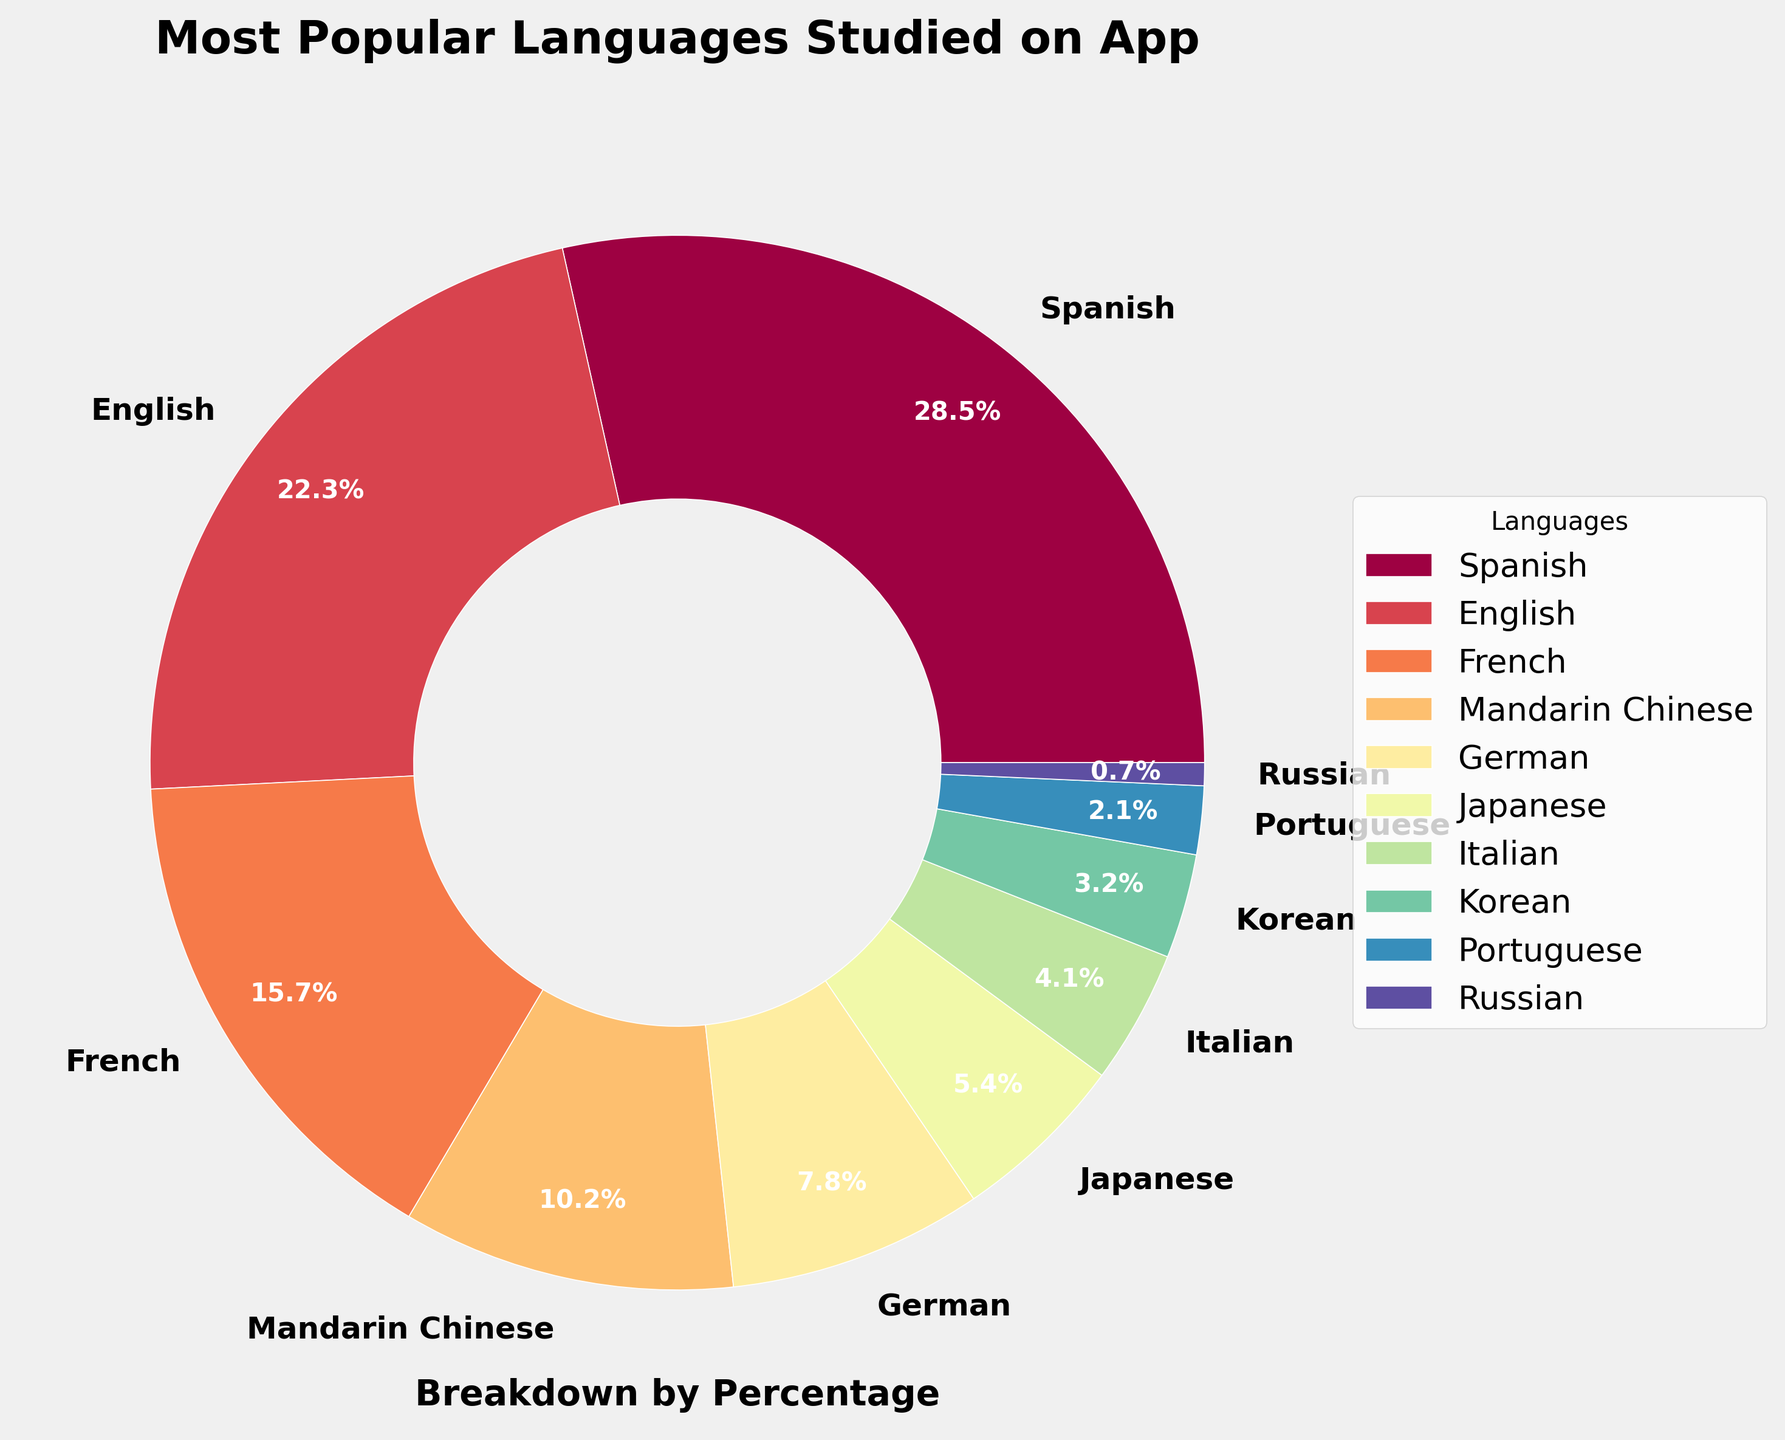What's the most popular language studied on the app? The pie chart shows the distribution of language popularity on the app. The Spanish section is the largest, making it the most popular language.
Answer: Spanish Which language has the smallest percentage of learners? By examining the pie chart, the smallest segment represents the language with the lowest percentage. In this case, it's Russian with 0.7%.
Answer: Russian How much higher is the percentage of learners studying Spanish compared to Mandarin Chinese? Spanish has 28.5% of learners, and Mandarin Chinese has 10.2%. Subtracting the two percentages: 28.5% - 10.2% = 18.3%.
Answer: 18.3% What is the combined percentage of learners studying Japanese and Korean? Japanese has 5.4%, and Korean has 3.2%. Adding these percentages together: 5.4% + 3.2% = 8.6%.
Answer: 8.6% Does French have a higher or lower percentage of learners than German? The pie chart shows that French has 15.7% and German has 7.8%. Since 15.7% is greater than 7.8%, French has a higher percentage.
Answer: Higher What is the percentage difference between English and French learners? English has 22.3%, and French has 15.7%. Subtracting the two percentages: 22.3% - 15.7% = 6.6%.
Answer: 6.6% Which segment in the pie chart is light blue, and what percentage does it represent? The light blue segment represents Mandarin Chinese, which has a 10.2% share.
Answer: Mandarin Chinese, 10.2% How many languages have more than 10% of learners? By examining the pie chart, Spanish, English, and French each have more than 10%. There are 3 languages in total.
Answer: 3 What is the combined percentage of learners studying the least popular three languages? The least popular three languages are Russian (0.7%), Portuguese (2.1%), and Korean (3.2%). Adding these percentages together: 0.7% + 2.1% + 3.2% = 6%.
Answer: 6% Among Spanish, French, and Italian, which language has the lowest percentage of learners? The pie chart shows Spanish with 28.5%, French with 15.7%, and Italian with 4.1%. Italian has the lowest percentage of learners.
Answer: Italian 